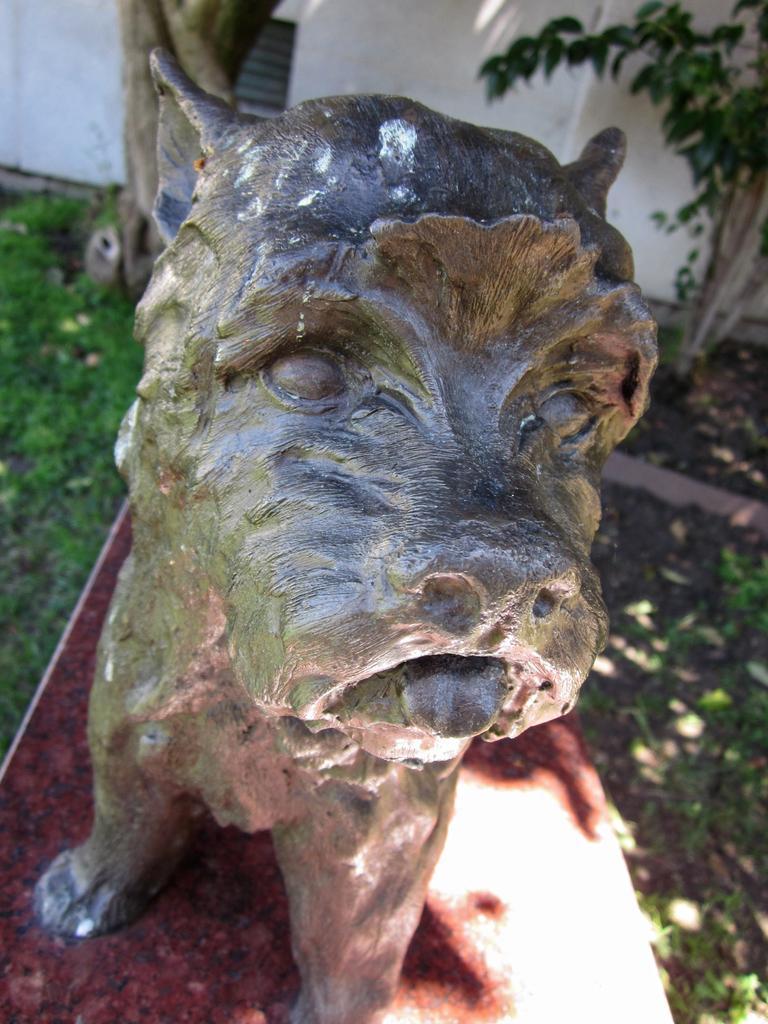Describe this image in one or two sentences. In this picture we can see a dog statue which is on the ground. On the left we can see grass. On the top right corner there is a plant near to the wall. 